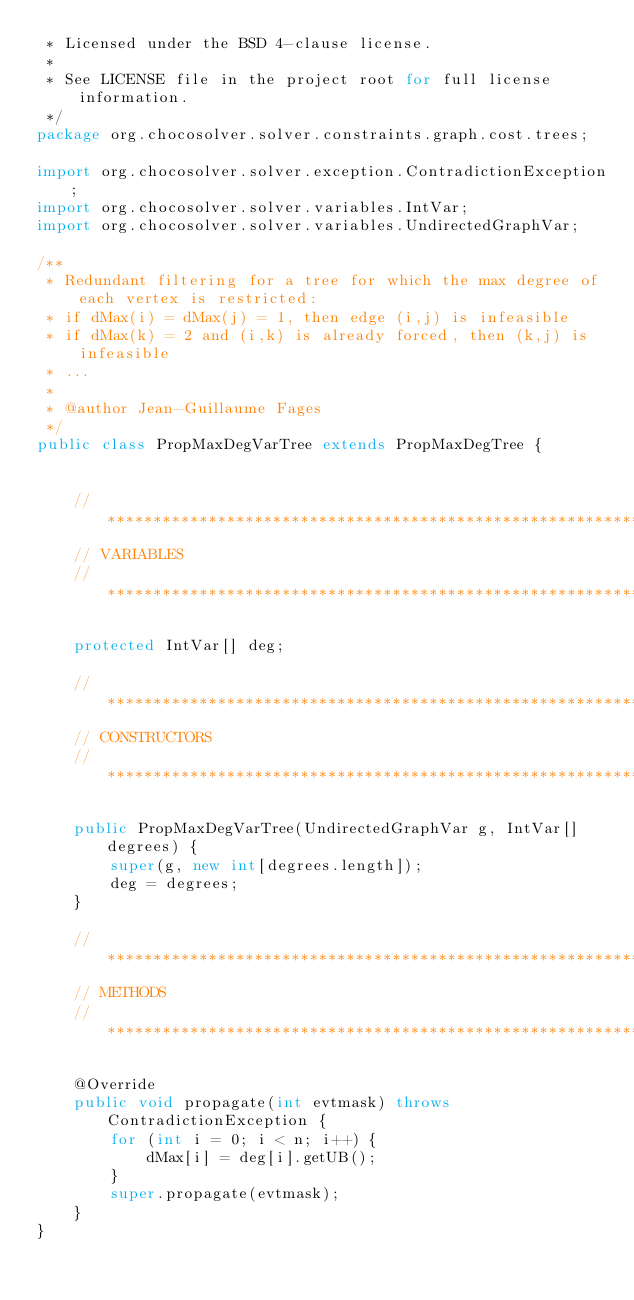<code> <loc_0><loc_0><loc_500><loc_500><_Java_> * Licensed under the BSD 4-clause license.
 *
 * See LICENSE file in the project root for full license information.
 */
package org.chocosolver.solver.constraints.graph.cost.trees;

import org.chocosolver.solver.exception.ContradictionException;
import org.chocosolver.solver.variables.IntVar;
import org.chocosolver.solver.variables.UndirectedGraphVar;

/**
 * Redundant filtering for a tree for which the max degree of each vertex is restricted:
 * if dMax(i) = dMax(j) = 1, then edge (i,j) is infeasible
 * if dMax(k) = 2 and (i,k) is already forced, then (k,j) is infeasible
 * ...
 *
 * @author Jean-Guillaume Fages
 */
public class PropMaxDegVarTree extends PropMaxDegTree {


    //***********************************************************************************
    // VARIABLES
    //***********************************************************************************

    protected IntVar[] deg;

    //***********************************************************************************
    // CONSTRUCTORS
    //***********************************************************************************

    public PropMaxDegVarTree(UndirectedGraphVar g, IntVar[] degrees) {
        super(g, new int[degrees.length]);
        deg = degrees;
    }

    //***********************************************************************************
    // METHODS
    //***********************************************************************************

    @Override
    public void propagate(int evtmask) throws ContradictionException {
        for (int i = 0; i < n; i++) {
            dMax[i] = deg[i].getUB();
        }
        super.propagate(evtmask);
    }
}
</code> 